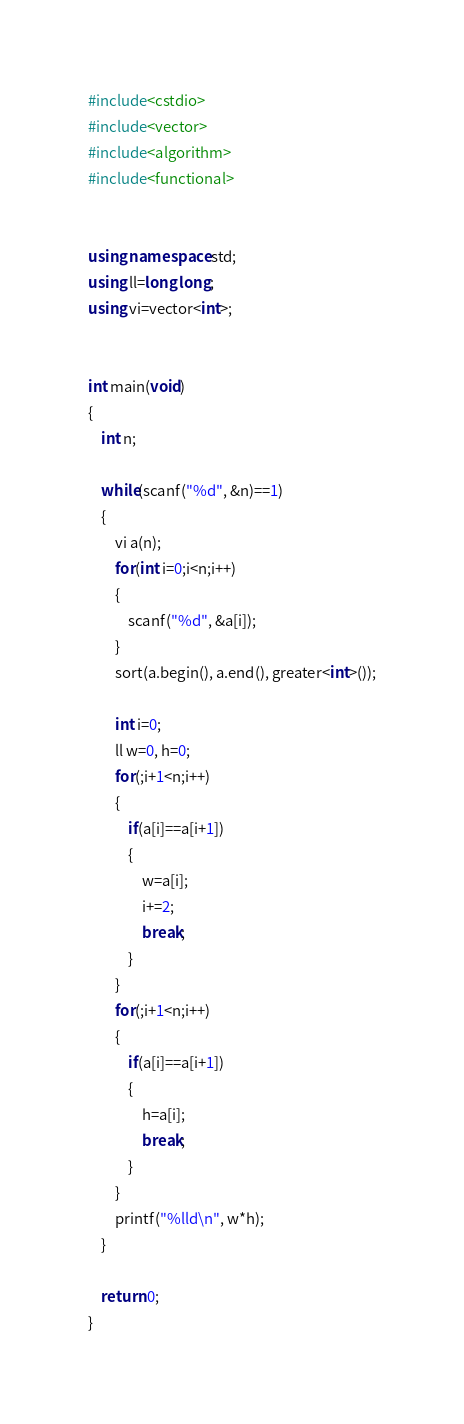Convert code to text. <code><loc_0><loc_0><loc_500><loc_500><_C++_>#include<cstdio>
#include<vector>
#include<algorithm>
#include<functional>


using namespace std;
using ll=long long;
using vi=vector<int>;


int main(void)
{
	int n;

	while(scanf("%d", &n)==1)
	{
		vi a(n);
		for(int i=0;i<n;i++)
		{
			scanf("%d", &a[i]);
		}
		sort(a.begin(), a.end(), greater<int>());

		int i=0;
		ll w=0, h=0;
		for(;i+1<n;i++)
		{
			if(a[i]==a[i+1])
			{
				w=a[i];
				i+=2;
				break;
			}
		}
		for(;i+1<n;i++)
		{
			if(a[i]==a[i+1])
			{
				h=a[i];
				break;
			}
		}
		printf("%lld\n", w*h);
	}

	return 0;
}
</code> 